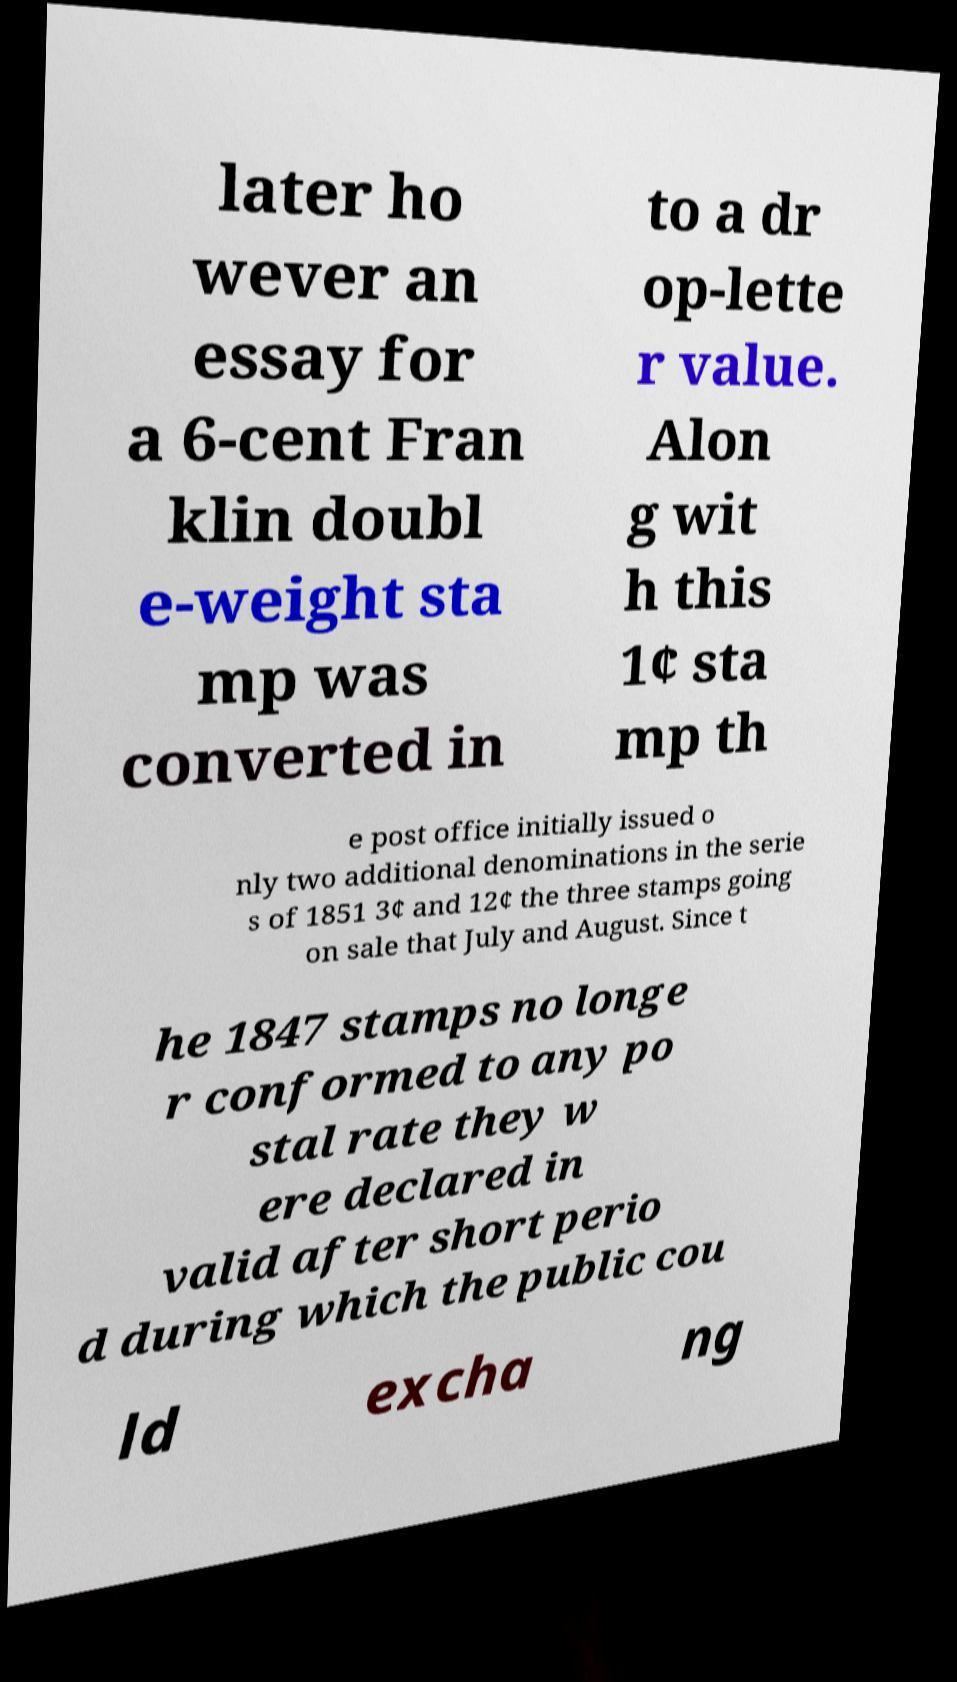Could you extract and type out the text from this image? later ho wever an essay for a 6-cent Fran klin doubl e-weight sta mp was converted in to a dr op-lette r value. Alon g wit h this 1¢ sta mp th e post office initially issued o nly two additional denominations in the serie s of 1851 3¢ and 12¢ the three stamps going on sale that July and August. Since t he 1847 stamps no longe r conformed to any po stal rate they w ere declared in valid after short perio d during which the public cou ld excha ng 